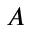Convert formula to latex. <formula><loc_0><loc_0><loc_500><loc_500>A</formula> 